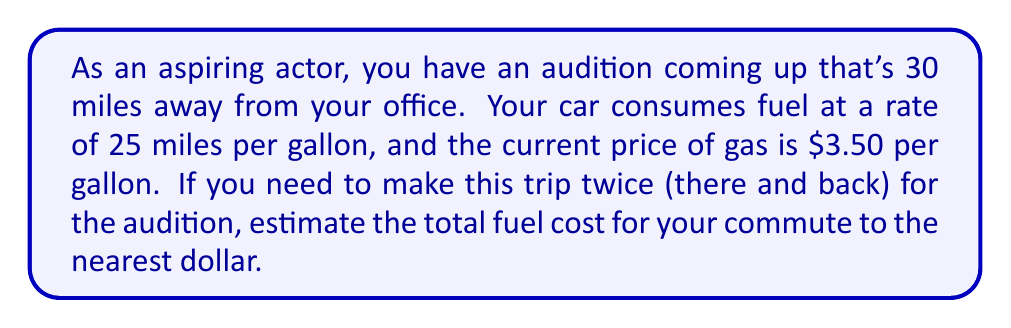What is the answer to this math problem? Let's break this problem down step-by-step:

1. Calculate the total distance:
   * One-way trip = 30 miles
   * Round trip = $30 \times 2 = 60$ miles

2. Calculate the amount of fuel needed:
   * Fuel efficiency = 25 miles per gallon
   * Fuel needed = $\frac{\text{Total distance}}{\text{Fuel efficiency}} = \frac{60 \text{ miles}}{25 \text{ miles/gallon}} = 2.4$ gallons

3. Calculate the cost of fuel:
   * Price of gas = $3.50 per gallon
   * Cost of fuel = $2.4 \text{ gallons} \times \$3.50/\text{gallon} = \$8.40$

4. Round to the nearest dollar:
   * $8.40 rounds to $8

Therefore, the estimated fuel cost for the commute to the audition is $8.
Answer: $8 